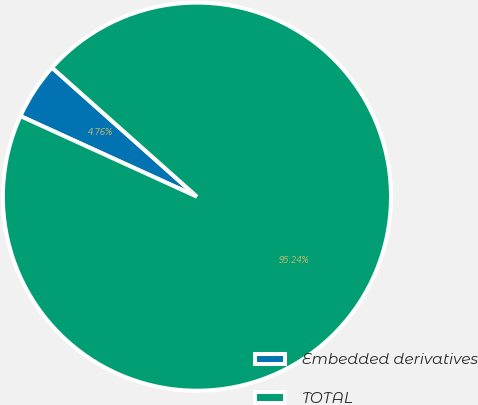Convert chart to OTSL. <chart><loc_0><loc_0><loc_500><loc_500><pie_chart><fcel>Embedded derivatives<fcel>TOTAL<nl><fcel>4.76%<fcel>95.24%<nl></chart> 